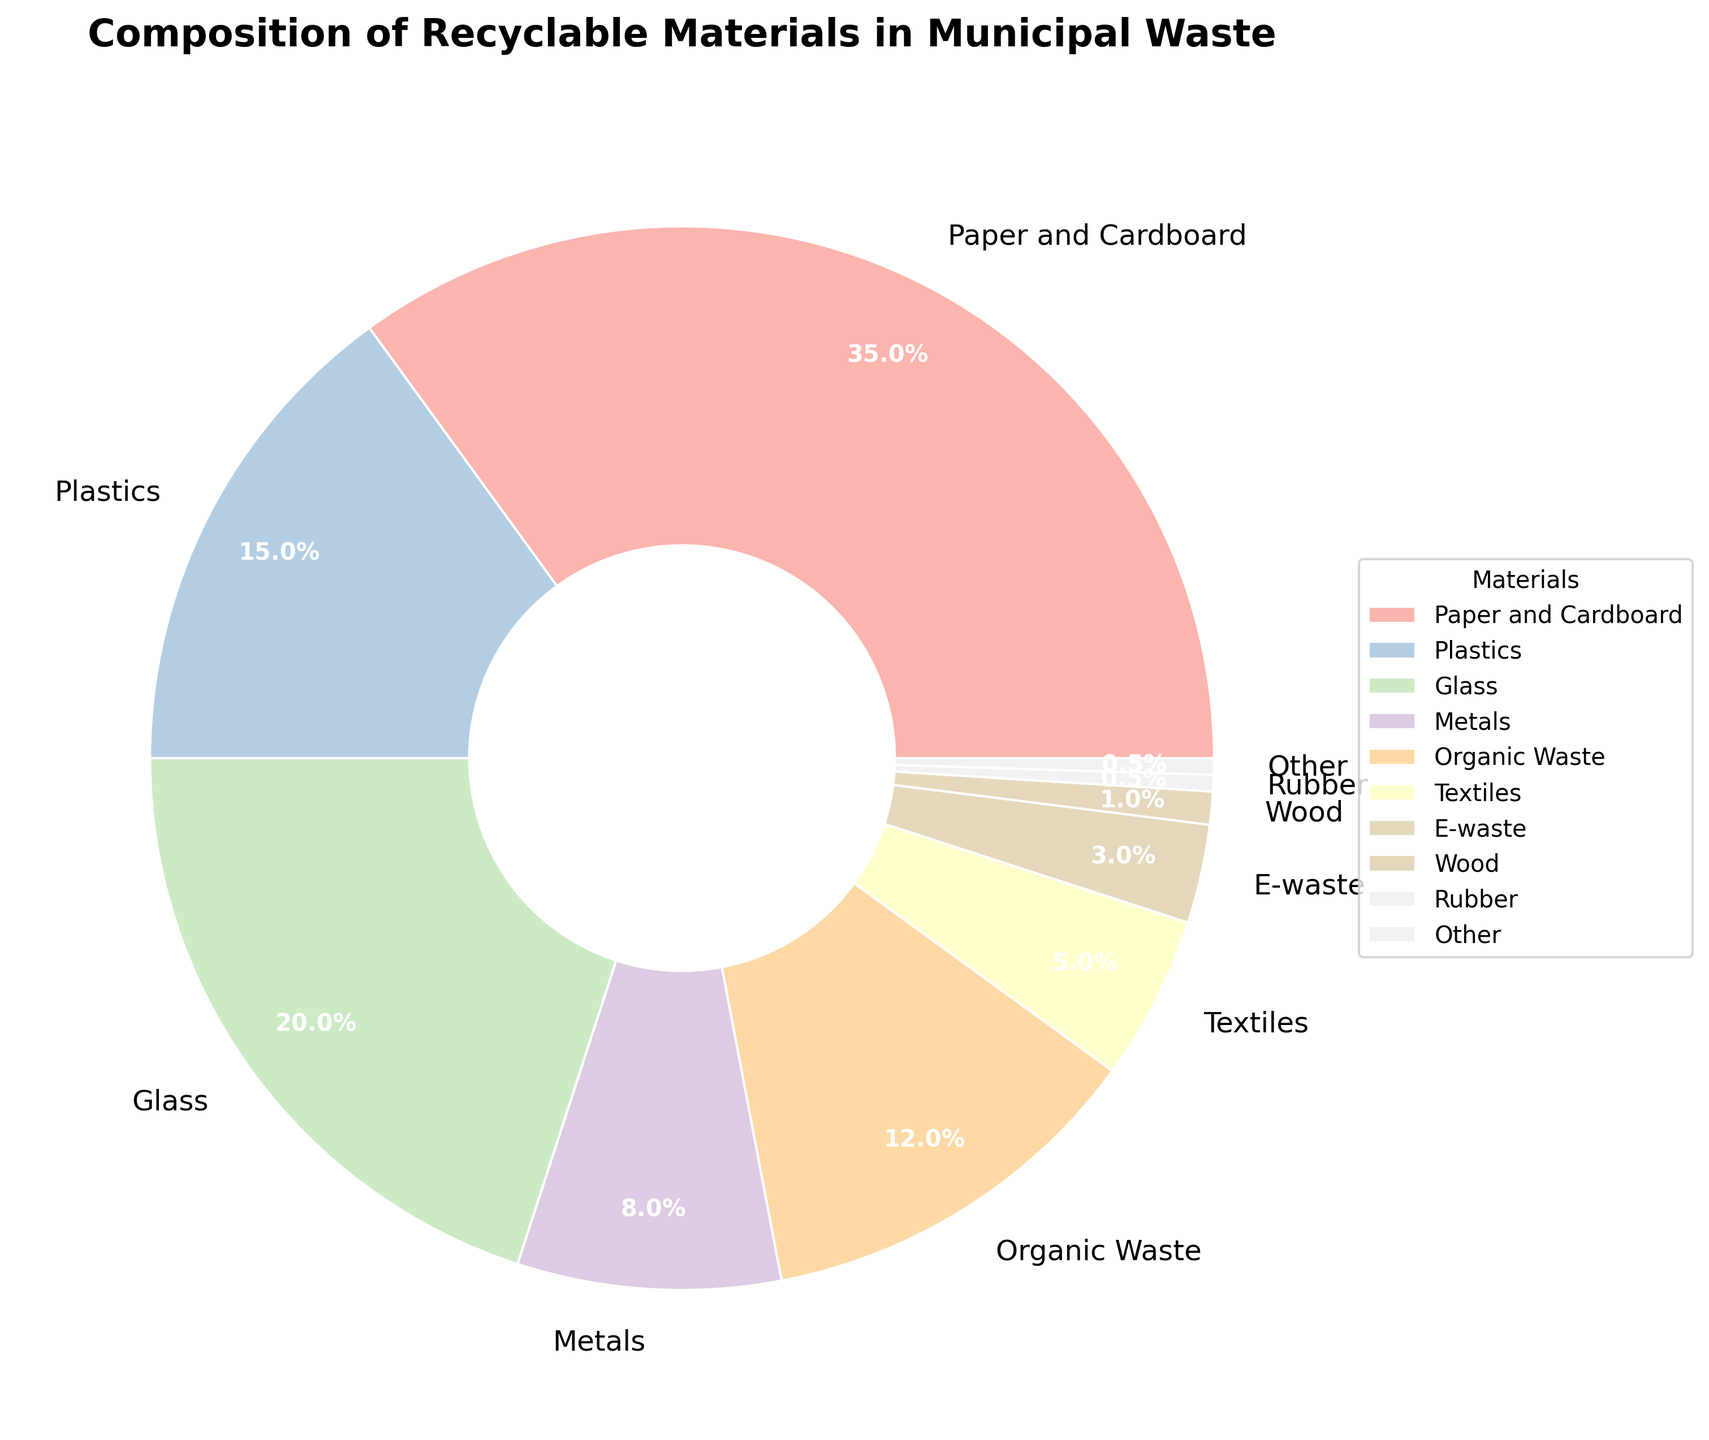What material makes up the highest percentage in the recyclable materials collected? To find this, look for the section of the pie chart with the largest area and check its label. The material labeled "Paper and Cardboard" occupies the largest section
Answer: Paper and Cardboard How much more percentage does Paper and Cardboard represent compared to Plastics? First, note the percentage for Paper and Cardboard (35%) and Plastics (15%). Subtract Plastic's percentage from that of Paper and Cardboard (35% - 15% = 20%)
Answer: 20% What is the combined percentage of Glass and Metals in the recyclable materials? Locate the percentages for Glass (20%) and Metals (8%). Add them together (20% + 8% = 28%)
Answer: 28% Which material has the lowest percentage in the recyclable materials and what is that percentage? Find the smallest section of the pie chart, which represents "Rubber" and "Other," both at 0.5%. Choose either one since they both have the lowest value.
Answer: Rubber or Other, 0.5% Is the percentage of Organic Waste greater than the sum of E-waste and Wood? Compare the percentage of Organic Waste (12%) with the sum of E-waste (3%) and Wood (1%). Sum E-waste and Wood (3% + 1% = 4%) and note that 12% is greater than 4%
Answer: Yes Combine the percentages of Textiles, E-waste, Wood, Rubber, and Other. What is their total contribution to recyclable materials? Note the percentages: Textiles (5%), E-waste (3%), Wood (1%), Rubber (0.5%), and Other (0.5%). Add them together (5% + 3% + 1% + 0.5% + 0.5% = 10%)
Answer: 10% What is the third most common material in the recyclable materials? Identify the materials with the highest, second highest, and next highest percentages. The first is Paper and Cardboard (35%), second is Glass (20%), and third is Plastics (15%)
Answer: Plastics If the sum of Plastics and Organic Waste is compared to Paper and Cardboard, is it greater? Calculate the sum of Plastics (15%) and Organic Waste (12%) (15% + 12% = 27%) and compare it with Paper and Cardboard (35%). Note that 27% is less than 35%
Answer: No What percentage of the materials is composed of metals and e-waste combined? Find the percentages for Metals (8%) and E-waste (3%). Add them together (8% + 3% = 11%)
Answer: 11% Which material occupies the section in red color and what is its percentage? Identify the section colored in red and check its label. According to the provided colors in the data, the section for Plastics seems to be red
Answer: Plastics, 15% 